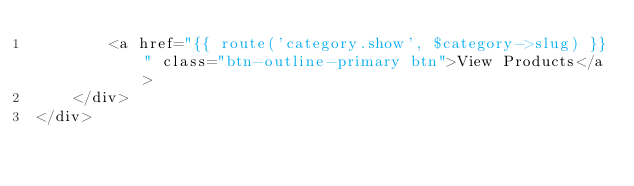Convert code to text. <code><loc_0><loc_0><loc_500><loc_500><_PHP_>        <a href="{{ route('category.show', $category->slug) }}" class="btn-outline-primary btn">View Products</a>
    </div>
</div>
</code> 